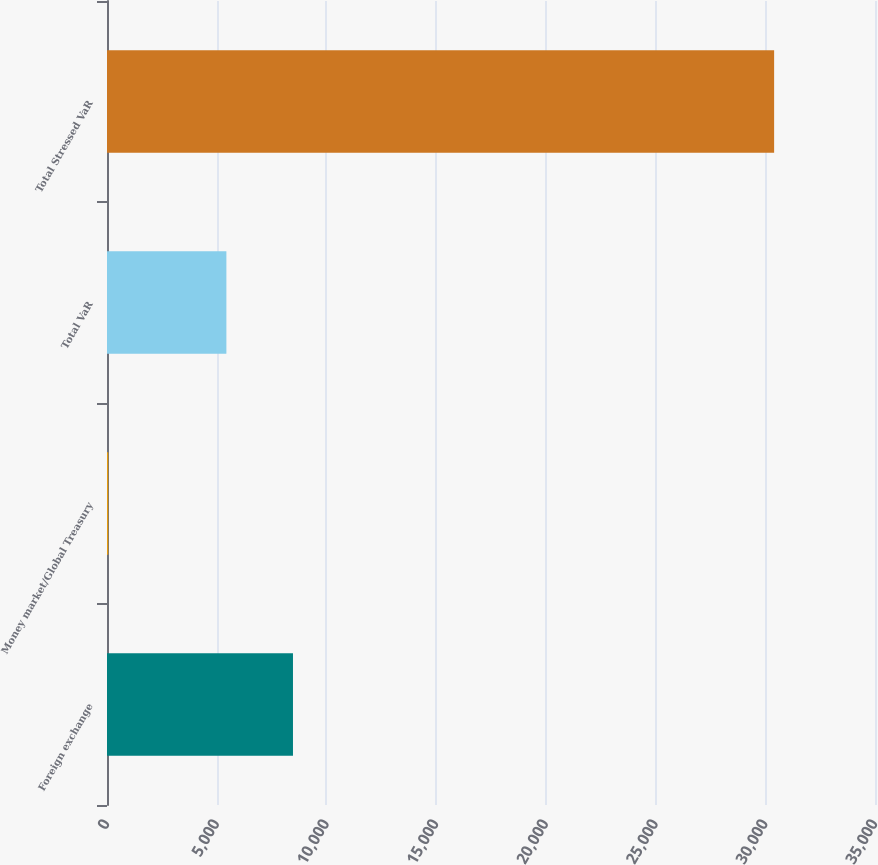Convert chart. <chart><loc_0><loc_0><loc_500><loc_500><bar_chart><fcel>Foreign exchange<fcel>Money market/Global Treasury<fcel>Total VaR<fcel>Total Stressed VaR<nl><fcel>8475.5<fcel>58<fcel>5441<fcel>30403<nl></chart> 